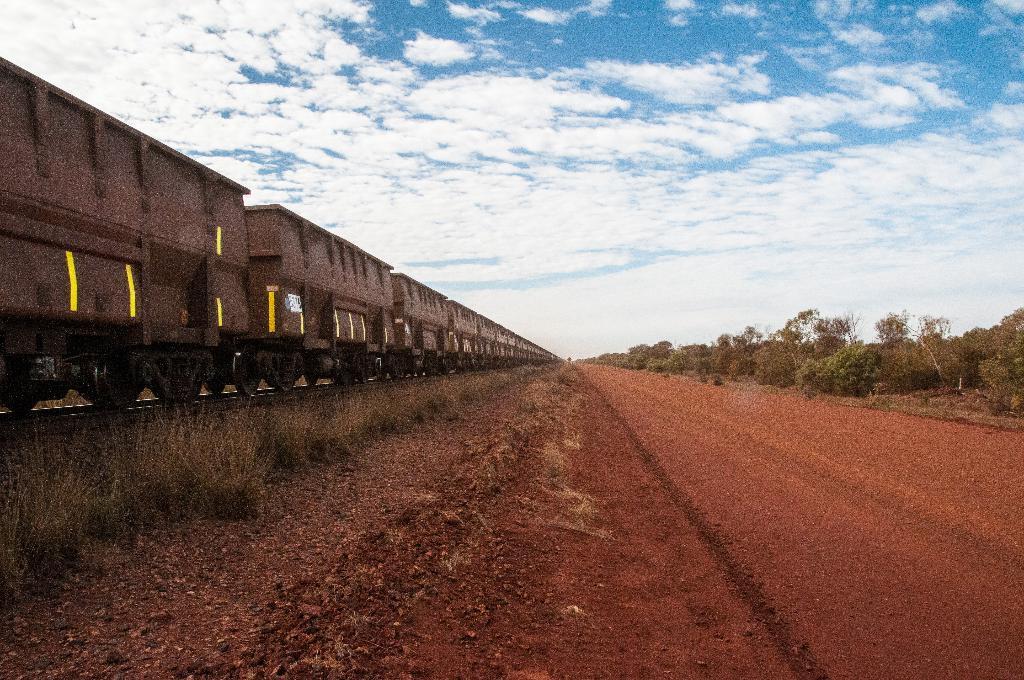In one or two sentences, can you explain what this image depicts? In this image we can see road. To the right side of the road trees are there and left side brain is present. The sky is in blue color with some clouds. 